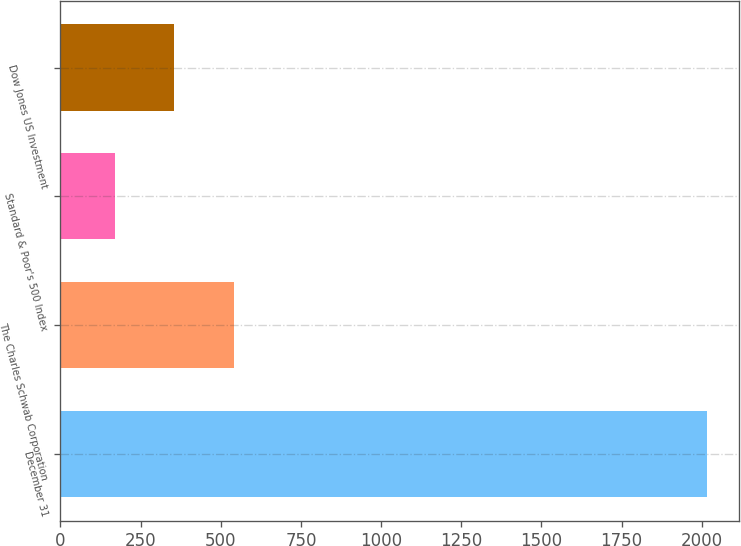Convert chart. <chart><loc_0><loc_0><loc_500><loc_500><bar_chart><fcel>December 31<fcel>The Charles Schwab Corporation<fcel>Standard & Poor's 500 Index<fcel>Dow Jones US Investment<nl><fcel>2016<fcel>540<fcel>171<fcel>355.5<nl></chart> 